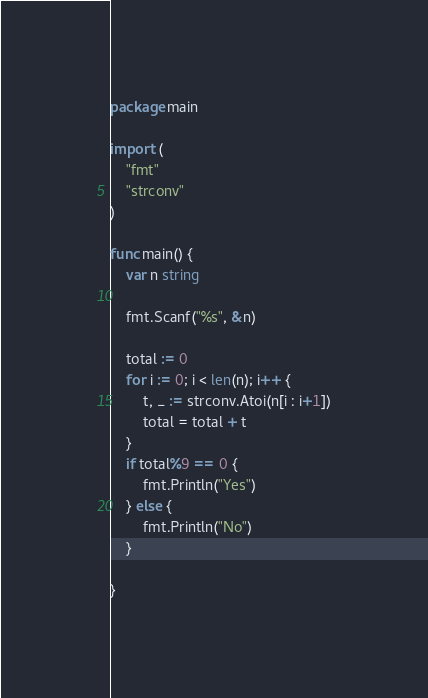Convert code to text. <code><loc_0><loc_0><loc_500><loc_500><_Go_>package main

import (
	"fmt"
	"strconv"
)

func main() {
	var n string

	fmt.Scanf("%s", &n)

	total := 0
	for i := 0; i < len(n); i++ {
		t, _ := strconv.Atoi(n[i : i+1])
		total = total + t
	}
	if total%9 == 0 {
		fmt.Println("Yes")
	} else {
		fmt.Println("No")
	}

}
</code> 